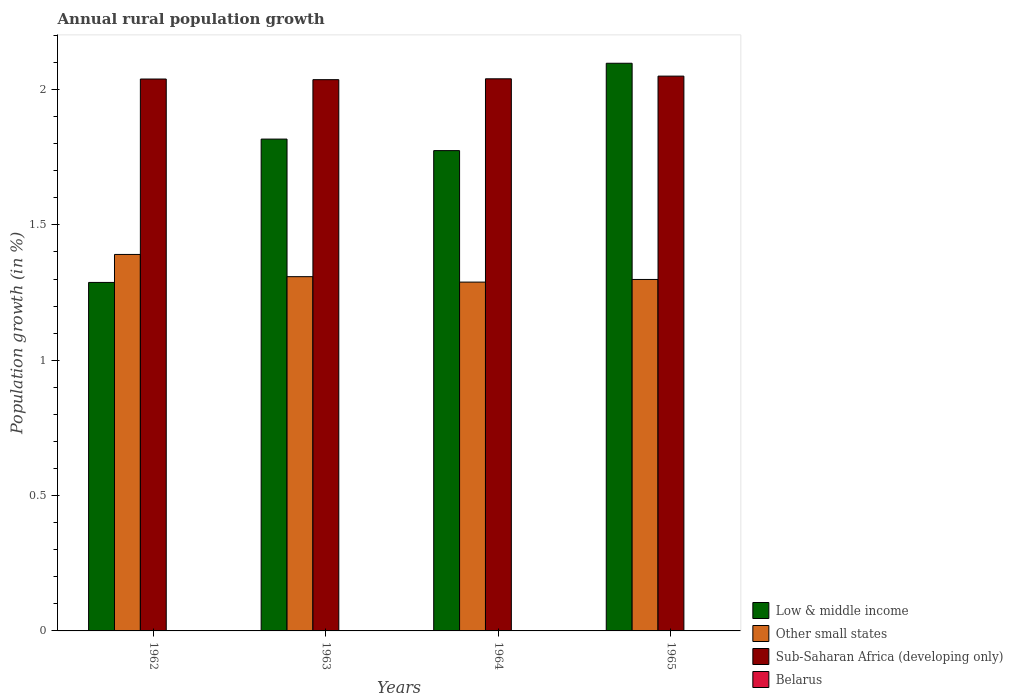How many different coloured bars are there?
Your answer should be very brief. 3. Are the number of bars per tick equal to the number of legend labels?
Keep it short and to the point. No. What is the label of the 1st group of bars from the left?
Provide a short and direct response. 1962. What is the percentage of rural population growth in Sub-Saharan Africa (developing only) in 1965?
Provide a short and direct response. 2.05. Across all years, what is the maximum percentage of rural population growth in Low & middle income?
Offer a very short reply. 2.1. In which year was the percentage of rural population growth in Other small states maximum?
Keep it short and to the point. 1962. What is the total percentage of rural population growth in Other small states in the graph?
Provide a succinct answer. 5.29. What is the difference between the percentage of rural population growth in Low & middle income in 1962 and that in 1964?
Offer a very short reply. -0.49. What is the difference between the percentage of rural population growth in Low & middle income in 1965 and the percentage of rural population growth in Sub-Saharan Africa (developing only) in 1962?
Offer a terse response. 0.06. What is the average percentage of rural population growth in Sub-Saharan Africa (developing only) per year?
Ensure brevity in your answer.  2.04. In the year 1962, what is the difference between the percentage of rural population growth in Other small states and percentage of rural population growth in Low & middle income?
Your answer should be compact. 0.1. In how many years, is the percentage of rural population growth in Other small states greater than 0.4 %?
Provide a short and direct response. 4. What is the ratio of the percentage of rural population growth in Low & middle income in 1963 to that in 1964?
Give a very brief answer. 1.02. Is the percentage of rural population growth in Sub-Saharan Africa (developing only) in 1963 less than that in 1965?
Offer a very short reply. Yes. Is the difference between the percentage of rural population growth in Other small states in 1964 and 1965 greater than the difference between the percentage of rural population growth in Low & middle income in 1964 and 1965?
Your answer should be compact. Yes. What is the difference between the highest and the second highest percentage of rural population growth in Sub-Saharan Africa (developing only)?
Ensure brevity in your answer.  0.01. What is the difference between the highest and the lowest percentage of rural population growth in Low & middle income?
Offer a terse response. 0.81. Is the sum of the percentage of rural population growth in Low & middle income in 1964 and 1965 greater than the maximum percentage of rural population growth in Belarus across all years?
Keep it short and to the point. Yes. Is it the case that in every year, the sum of the percentage of rural population growth in Low & middle income and percentage of rural population growth in Sub-Saharan Africa (developing only) is greater than the sum of percentage of rural population growth in Belarus and percentage of rural population growth in Other small states?
Provide a short and direct response. No. How many bars are there?
Offer a terse response. 12. What is the difference between two consecutive major ticks on the Y-axis?
Provide a succinct answer. 0.5. Does the graph contain any zero values?
Ensure brevity in your answer.  Yes. How many legend labels are there?
Provide a succinct answer. 4. What is the title of the graph?
Provide a succinct answer. Annual rural population growth. What is the label or title of the Y-axis?
Offer a terse response. Population growth (in %). What is the Population growth (in %) in Low & middle income in 1962?
Give a very brief answer. 1.29. What is the Population growth (in %) of Other small states in 1962?
Offer a very short reply. 1.39. What is the Population growth (in %) in Sub-Saharan Africa (developing only) in 1962?
Give a very brief answer. 2.04. What is the Population growth (in %) in Belarus in 1962?
Your answer should be compact. 0. What is the Population growth (in %) of Low & middle income in 1963?
Ensure brevity in your answer.  1.82. What is the Population growth (in %) in Other small states in 1963?
Your answer should be very brief. 1.31. What is the Population growth (in %) of Sub-Saharan Africa (developing only) in 1963?
Give a very brief answer. 2.04. What is the Population growth (in %) in Low & middle income in 1964?
Offer a very short reply. 1.77. What is the Population growth (in %) of Other small states in 1964?
Your response must be concise. 1.29. What is the Population growth (in %) in Sub-Saharan Africa (developing only) in 1964?
Keep it short and to the point. 2.04. What is the Population growth (in %) in Low & middle income in 1965?
Make the answer very short. 2.1. What is the Population growth (in %) in Other small states in 1965?
Offer a terse response. 1.3. What is the Population growth (in %) of Sub-Saharan Africa (developing only) in 1965?
Give a very brief answer. 2.05. What is the Population growth (in %) of Belarus in 1965?
Ensure brevity in your answer.  0. Across all years, what is the maximum Population growth (in %) in Low & middle income?
Your answer should be very brief. 2.1. Across all years, what is the maximum Population growth (in %) of Other small states?
Offer a very short reply. 1.39. Across all years, what is the maximum Population growth (in %) of Sub-Saharan Africa (developing only)?
Make the answer very short. 2.05. Across all years, what is the minimum Population growth (in %) of Low & middle income?
Your answer should be very brief. 1.29. Across all years, what is the minimum Population growth (in %) of Other small states?
Provide a short and direct response. 1.29. Across all years, what is the minimum Population growth (in %) in Sub-Saharan Africa (developing only)?
Your answer should be very brief. 2.04. What is the total Population growth (in %) in Low & middle income in the graph?
Your response must be concise. 6.98. What is the total Population growth (in %) in Other small states in the graph?
Offer a very short reply. 5.29. What is the total Population growth (in %) in Sub-Saharan Africa (developing only) in the graph?
Offer a terse response. 8.16. What is the difference between the Population growth (in %) in Low & middle income in 1962 and that in 1963?
Your answer should be compact. -0.53. What is the difference between the Population growth (in %) of Other small states in 1962 and that in 1963?
Keep it short and to the point. 0.08. What is the difference between the Population growth (in %) in Sub-Saharan Africa (developing only) in 1962 and that in 1963?
Your answer should be very brief. 0. What is the difference between the Population growth (in %) of Low & middle income in 1962 and that in 1964?
Give a very brief answer. -0.49. What is the difference between the Population growth (in %) in Other small states in 1962 and that in 1964?
Ensure brevity in your answer.  0.1. What is the difference between the Population growth (in %) of Sub-Saharan Africa (developing only) in 1962 and that in 1964?
Offer a very short reply. -0. What is the difference between the Population growth (in %) in Low & middle income in 1962 and that in 1965?
Offer a terse response. -0.81. What is the difference between the Population growth (in %) of Other small states in 1962 and that in 1965?
Offer a terse response. 0.09. What is the difference between the Population growth (in %) in Sub-Saharan Africa (developing only) in 1962 and that in 1965?
Offer a terse response. -0.01. What is the difference between the Population growth (in %) of Low & middle income in 1963 and that in 1964?
Provide a short and direct response. 0.04. What is the difference between the Population growth (in %) of Other small states in 1963 and that in 1964?
Provide a short and direct response. 0.02. What is the difference between the Population growth (in %) in Sub-Saharan Africa (developing only) in 1963 and that in 1964?
Provide a short and direct response. -0. What is the difference between the Population growth (in %) in Low & middle income in 1963 and that in 1965?
Offer a very short reply. -0.28. What is the difference between the Population growth (in %) of Other small states in 1963 and that in 1965?
Provide a succinct answer. 0.01. What is the difference between the Population growth (in %) of Sub-Saharan Africa (developing only) in 1963 and that in 1965?
Give a very brief answer. -0.01. What is the difference between the Population growth (in %) of Low & middle income in 1964 and that in 1965?
Offer a very short reply. -0.32. What is the difference between the Population growth (in %) in Other small states in 1964 and that in 1965?
Keep it short and to the point. -0.01. What is the difference between the Population growth (in %) of Sub-Saharan Africa (developing only) in 1964 and that in 1965?
Give a very brief answer. -0.01. What is the difference between the Population growth (in %) in Low & middle income in 1962 and the Population growth (in %) in Other small states in 1963?
Your answer should be compact. -0.02. What is the difference between the Population growth (in %) in Low & middle income in 1962 and the Population growth (in %) in Sub-Saharan Africa (developing only) in 1963?
Give a very brief answer. -0.75. What is the difference between the Population growth (in %) of Other small states in 1962 and the Population growth (in %) of Sub-Saharan Africa (developing only) in 1963?
Provide a short and direct response. -0.65. What is the difference between the Population growth (in %) of Low & middle income in 1962 and the Population growth (in %) of Other small states in 1964?
Keep it short and to the point. -0. What is the difference between the Population growth (in %) in Low & middle income in 1962 and the Population growth (in %) in Sub-Saharan Africa (developing only) in 1964?
Keep it short and to the point. -0.75. What is the difference between the Population growth (in %) of Other small states in 1962 and the Population growth (in %) of Sub-Saharan Africa (developing only) in 1964?
Your answer should be compact. -0.65. What is the difference between the Population growth (in %) of Low & middle income in 1962 and the Population growth (in %) of Other small states in 1965?
Your response must be concise. -0.01. What is the difference between the Population growth (in %) in Low & middle income in 1962 and the Population growth (in %) in Sub-Saharan Africa (developing only) in 1965?
Give a very brief answer. -0.76. What is the difference between the Population growth (in %) in Other small states in 1962 and the Population growth (in %) in Sub-Saharan Africa (developing only) in 1965?
Provide a short and direct response. -0.66. What is the difference between the Population growth (in %) of Low & middle income in 1963 and the Population growth (in %) of Other small states in 1964?
Keep it short and to the point. 0.53. What is the difference between the Population growth (in %) in Low & middle income in 1963 and the Population growth (in %) in Sub-Saharan Africa (developing only) in 1964?
Keep it short and to the point. -0.22. What is the difference between the Population growth (in %) of Other small states in 1963 and the Population growth (in %) of Sub-Saharan Africa (developing only) in 1964?
Ensure brevity in your answer.  -0.73. What is the difference between the Population growth (in %) of Low & middle income in 1963 and the Population growth (in %) of Other small states in 1965?
Keep it short and to the point. 0.52. What is the difference between the Population growth (in %) of Low & middle income in 1963 and the Population growth (in %) of Sub-Saharan Africa (developing only) in 1965?
Offer a terse response. -0.23. What is the difference between the Population growth (in %) of Other small states in 1963 and the Population growth (in %) of Sub-Saharan Africa (developing only) in 1965?
Your answer should be very brief. -0.74. What is the difference between the Population growth (in %) of Low & middle income in 1964 and the Population growth (in %) of Other small states in 1965?
Make the answer very short. 0.48. What is the difference between the Population growth (in %) of Low & middle income in 1964 and the Population growth (in %) of Sub-Saharan Africa (developing only) in 1965?
Offer a very short reply. -0.28. What is the difference between the Population growth (in %) in Other small states in 1964 and the Population growth (in %) in Sub-Saharan Africa (developing only) in 1965?
Offer a terse response. -0.76. What is the average Population growth (in %) in Low & middle income per year?
Your response must be concise. 1.74. What is the average Population growth (in %) of Other small states per year?
Make the answer very short. 1.32. What is the average Population growth (in %) of Sub-Saharan Africa (developing only) per year?
Your response must be concise. 2.04. What is the average Population growth (in %) of Belarus per year?
Provide a short and direct response. 0. In the year 1962, what is the difference between the Population growth (in %) of Low & middle income and Population growth (in %) of Other small states?
Provide a succinct answer. -0.1. In the year 1962, what is the difference between the Population growth (in %) in Low & middle income and Population growth (in %) in Sub-Saharan Africa (developing only)?
Offer a terse response. -0.75. In the year 1962, what is the difference between the Population growth (in %) in Other small states and Population growth (in %) in Sub-Saharan Africa (developing only)?
Keep it short and to the point. -0.65. In the year 1963, what is the difference between the Population growth (in %) in Low & middle income and Population growth (in %) in Other small states?
Your response must be concise. 0.51. In the year 1963, what is the difference between the Population growth (in %) in Low & middle income and Population growth (in %) in Sub-Saharan Africa (developing only)?
Keep it short and to the point. -0.22. In the year 1963, what is the difference between the Population growth (in %) of Other small states and Population growth (in %) of Sub-Saharan Africa (developing only)?
Give a very brief answer. -0.73. In the year 1964, what is the difference between the Population growth (in %) in Low & middle income and Population growth (in %) in Other small states?
Offer a terse response. 0.49. In the year 1964, what is the difference between the Population growth (in %) in Low & middle income and Population growth (in %) in Sub-Saharan Africa (developing only)?
Your answer should be compact. -0.27. In the year 1964, what is the difference between the Population growth (in %) in Other small states and Population growth (in %) in Sub-Saharan Africa (developing only)?
Your answer should be compact. -0.75. In the year 1965, what is the difference between the Population growth (in %) of Low & middle income and Population growth (in %) of Other small states?
Your response must be concise. 0.8. In the year 1965, what is the difference between the Population growth (in %) of Low & middle income and Population growth (in %) of Sub-Saharan Africa (developing only)?
Your answer should be very brief. 0.05. In the year 1965, what is the difference between the Population growth (in %) of Other small states and Population growth (in %) of Sub-Saharan Africa (developing only)?
Your answer should be compact. -0.75. What is the ratio of the Population growth (in %) in Low & middle income in 1962 to that in 1963?
Ensure brevity in your answer.  0.71. What is the ratio of the Population growth (in %) in Other small states in 1962 to that in 1963?
Offer a terse response. 1.06. What is the ratio of the Population growth (in %) in Sub-Saharan Africa (developing only) in 1962 to that in 1963?
Give a very brief answer. 1. What is the ratio of the Population growth (in %) of Low & middle income in 1962 to that in 1964?
Offer a terse response. 0.73. What is the ratio of the Population growth (in %) in Other small states in 1962 to that in 1964?
Offer a terse response. 1.08. What is the ratio of the Population growth (in %) in Sub-Saharan Africa (developing only) in 1962 to that in 1964?
Give a very brief answer. 1. What is the ratio of the Population growth (in %) in Low & middle income in 1962 to that in 1965?
Give a very brief answer. 0.61. What is the ratio of the Population growth (in %) of Other small states in 1962 to that in 1965?
Your response must be concise. 1.07. What is the ratio of the Population growth (in %) of Low & middle income in 1963 to that in 1964?
Your answer should be compact. 1.02. What is the ratio of the Population growth (in %) in Other small states in 1963 to that in 1964?
Provide a succinct answer. 1.02. What is the ratio of the Population growth (in %) of Sub-Saharan Africa (developing only) in 1963 to that in 1964?
Provide a succinct answer. 1. What is the ratio of the Population growth (in %) of Low & middle income in 1963 to that in 1965?
Offer a terse response. 0.87. What is the ratio of the Population growth (in %) in Other small states in 1963 to that in 1965?
Provide a short and direct response. 1.01. What is the ratio of the Population growth (in %) of Low & middle income in 1964 to that in 1965?
Make the answer very short. 0.85. What is the ratio of the Population growth (in %) of Other small states in 1964 to that in 1965?
Your answer should be very brief. 0.99. What is the difference between the highest and the second highest Population growth (in %) of Low & middle income?
Offer a very short reply. 0.28. What is the difference between the highest and the second highest Population growth (in %) of Other small states?
Offer a terse response. 0.08. What is the difference between the highest and the second highest Population growth (in %) in Sub-Saharan Africa (developing only)?
Offer a very short reply. 0.01. What is the difference between the highest and the lowest Population growth (in %) in Low & middle income?
Your response must be concise. 0.81. What is the difference between the highest and the lowest Population growth (in %) of Other small states?
Provide a succinct answer. 0.1. What is the difference between the highest and the lowest Population growth (in %) in Sub-Saharan Africa (developing only)?
Give a very brief answer. 0.01. 